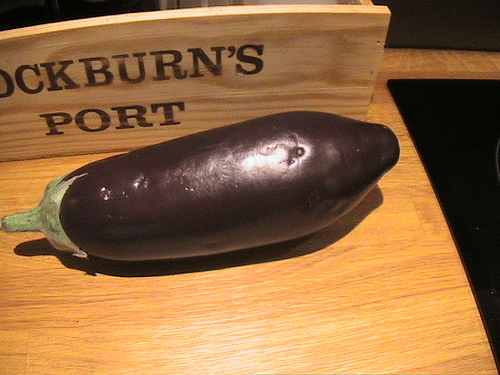<image>
Is there a eggplant in front of the table? No. The eggplant is not in front of the table. The spatial positioning shows a different relationship between these objects. 